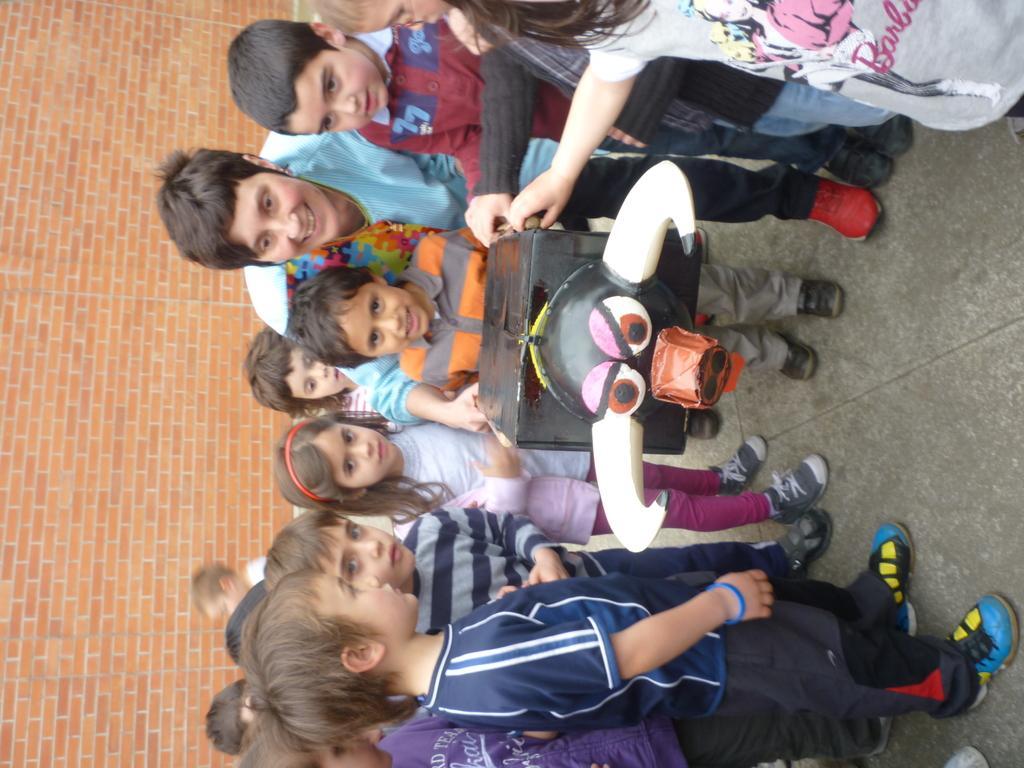In one or two sentences, can you explain what this image depicts? In this image there are group of children standing on the road by holding the box. At the back side there is a wall. 